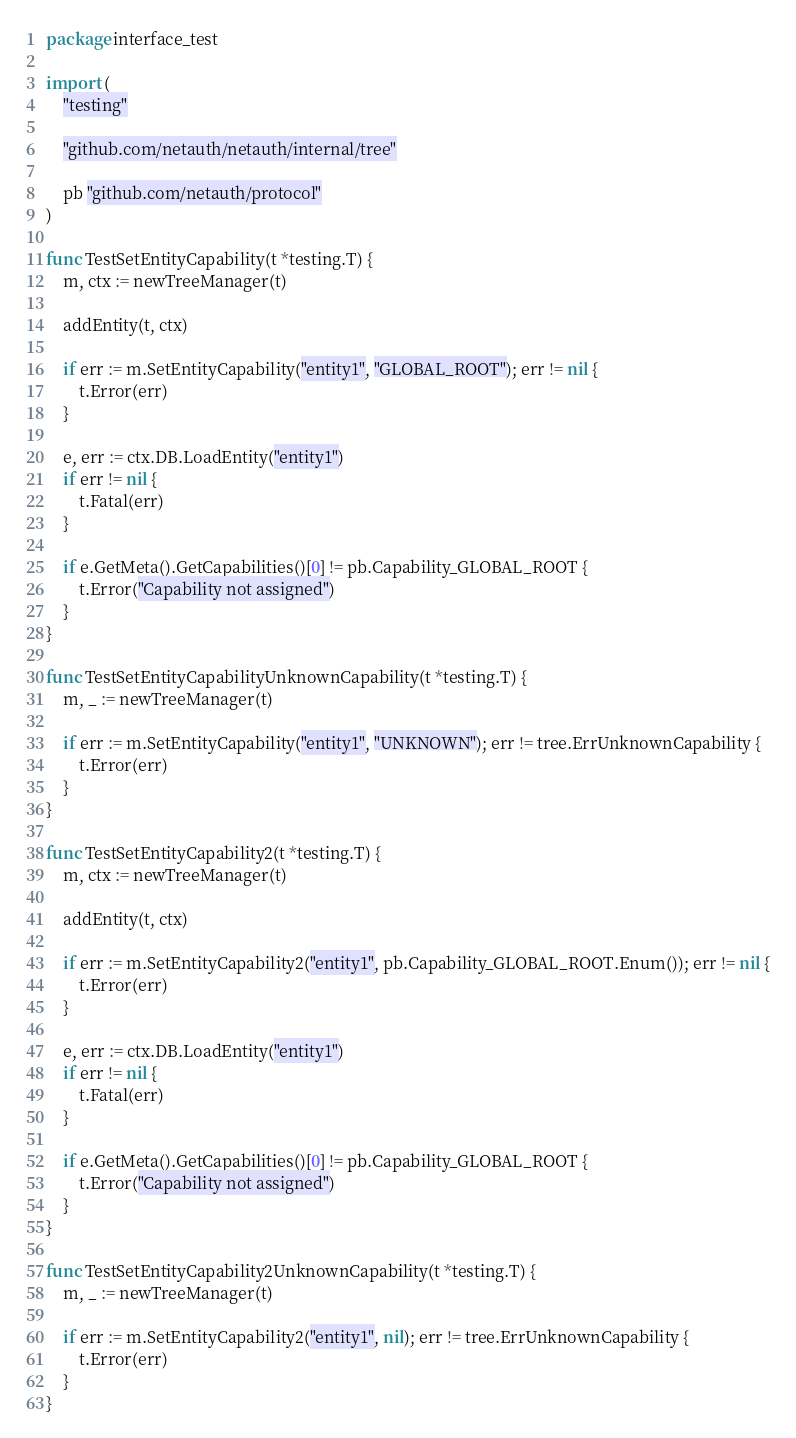<code> <loc_0><loc_0><loc_500><loc_500><_Go_>package interface_test

import (
	"testing"

	"github.com/netauth/netauth/internal/tree"

	pb "github.com/netauth/protocol"
)

func TestSetEntityCapability(t *testing.T) {
	m, ctx := newTreeManager(t)

	addEntity(t, ctx)

	if err := m.SetEntityCapability("entity1", "GLOBAL_ROOT"); err != nil {
		t.Error(err)
	}

	e, err := ctx.DB.LoadEntity("entity1")
	if err != nil {
		t.Fatal(err)
	}

	if e.GetMeta().GetCapabilities()[0] != pb.Capability_GLOBAL_ROOT {
		t.Error("Capability not assigned")
	}
}

func TestSetEntityCapabilityUnknownCapability(t *testing.T) {
	m, _ := newTreeManager(t)

	if err := m.SetEntityCapability("entity1", "UNKNOWN"); err != tree.ErrUnknownCapability {
		t.Error(err)
	}
}

func TestSetEntityCapability2(t *testing.T) {
	m, ctx := newTreeManager(t)

	addEntity(t, ctx)

	if err := m.SetEntityCapability2("entity1", pb.Capability_GLOBAL_ROOT.Enum()); err != nil {
		t.Error(err)
	}

	e, err := ctx.DB.LoadEntity("entity1")
	if err != nil {
		t.Fatal(err)
	}

	if e.GetMeta().GetCapabilities()[0] != pb.Capability_GLOBAL_ROOT {
		t.Error("Capability not assigned")
	}
}

func TestSetEntityCapability2UnknownCapability(t *testing.T) {
	m, _ := newTreeManager(t)

	if err := m.SetEntityCapability2("entity1", nil); err != tree.ErrUnknownCapability {
		t.Error(err)
	}
}
</code> 